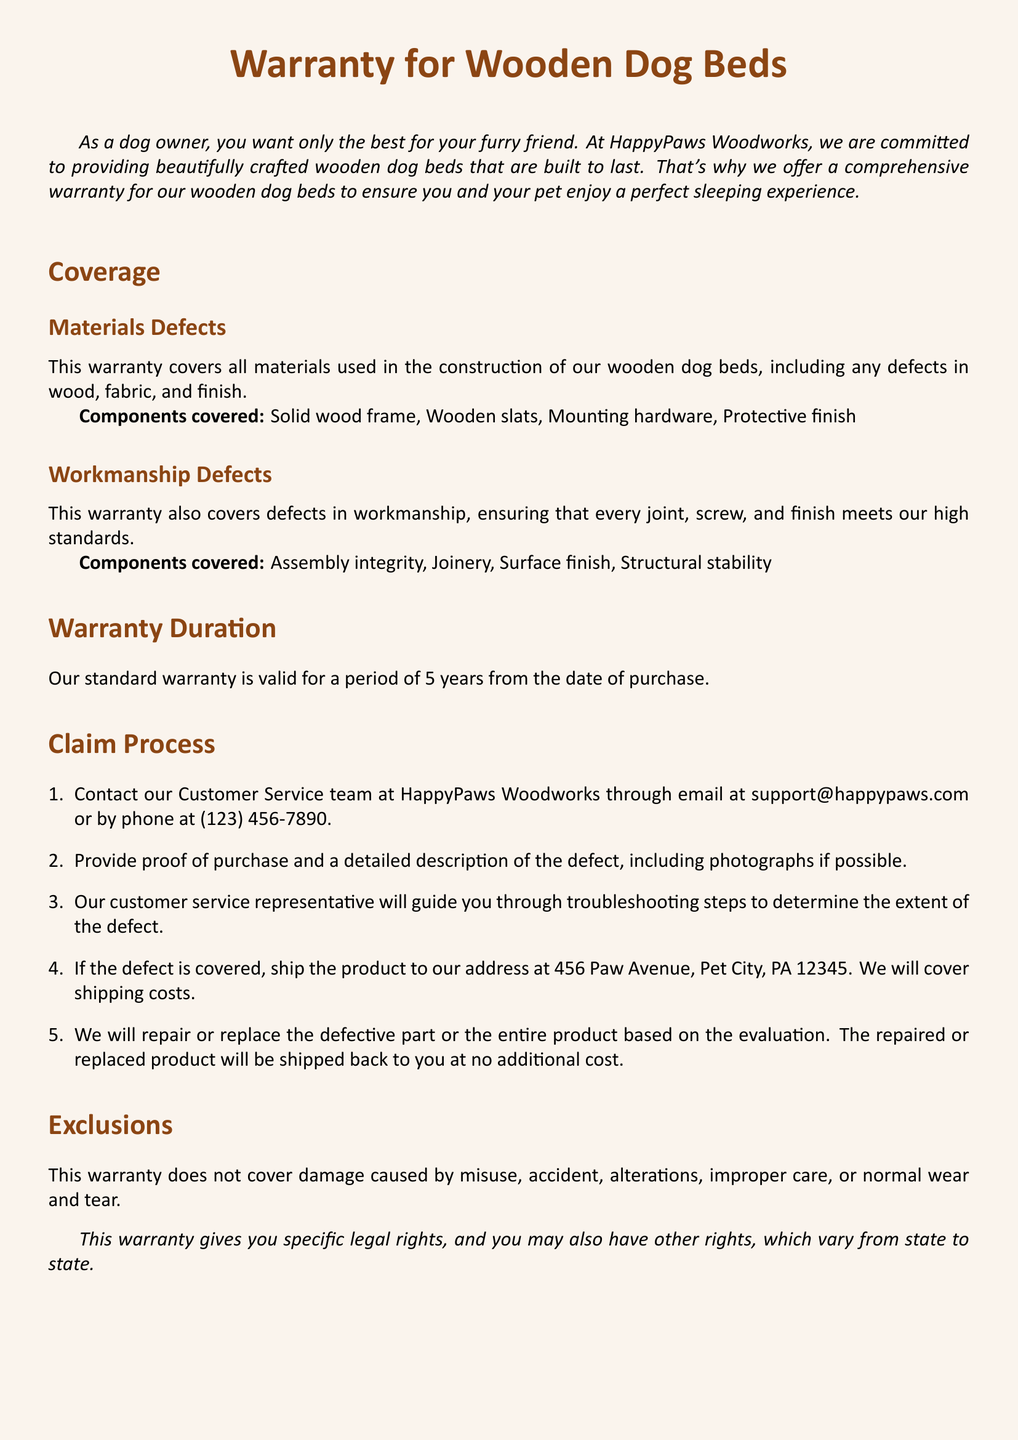What is the warranty duration? The warranty duration is clearly stated in the document as the period during which the warranty is valid from the date of purchase.
Answer: 5 years Which components are covered under materials defects? The document lists specific parts that are included under materials defects coverage.
Answer: Solid wood frame, Wooden slats, Mounting hardware, Protective finish What must be provided to claim a warranty? The document specifies what information is needed to initiate a warranty claim process, focusing on proof and description of the issue.
Answer: Proof of purchase and a detailed description of the defect Who should be contacted for warranty claims? The document names the specific team or contact for addressing warranty issues and inquiries.
Answer: Customer Service team What does the warranty exclude? The exclusions of the warranty are outlined to clarify what types of damage or issues are not covered by the warranty.
Answer: Misuse, accident, alterations, improper care, or normal wear and tear What is the initial step in the claim process? The claim process has a specified first step that initiates the procedure for receiving warranty service.
Answer: Contact our Customer Service team How is shipping handled for returns? The document explains how shipping costs are managed in relation to warranty claims and product returns.
Answer: We will cover shipping costs Which types of defects does the warranty cover? The warranty's coverage includes two main categories that ensure standards are met and products are functional.
Answer: Materials and Workmanship defects 